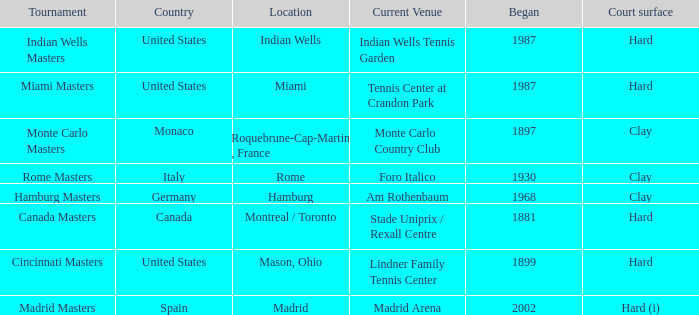Which current venues location is Mason, Ohio? Lindner Family Tennis Center. 